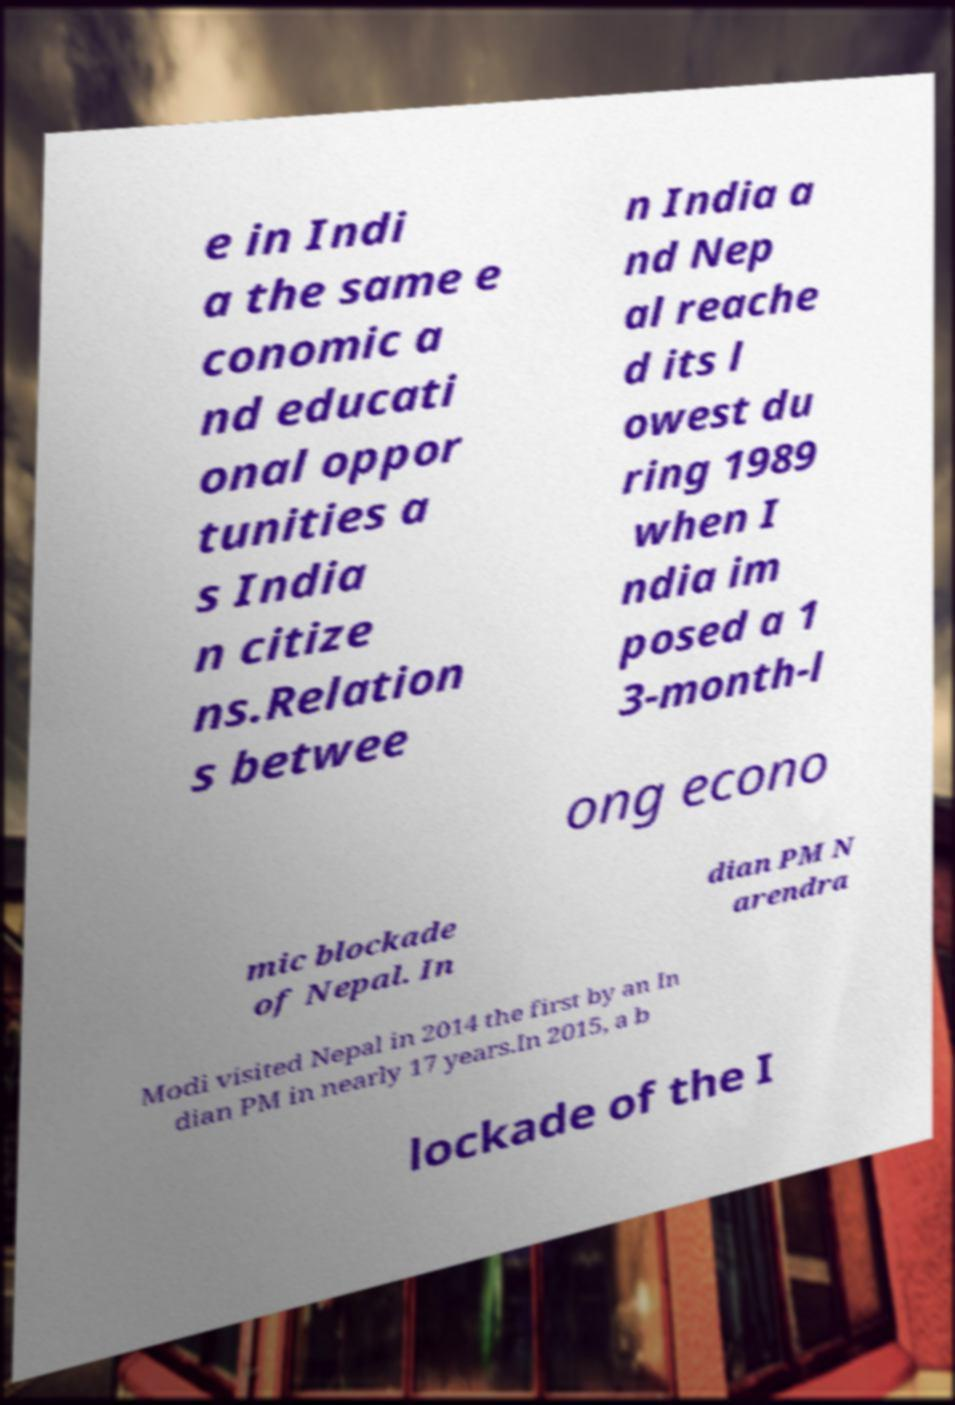Please identify and transcribe the text found in this image. e in Indi a the same e conomic a nd educati onal oppor tunities a s India n citize ns.Relation s betwee n India a nd Nep al reache d its l owest du ring 1989 when I ndia im posed a 1 3-month-l ong econo mic blockade of Nepal. In dian PM N arendra Modi visited Nepal in 2014 the first by an In dian PM in nearly 17 years.In 2015, a b lockade of the I 